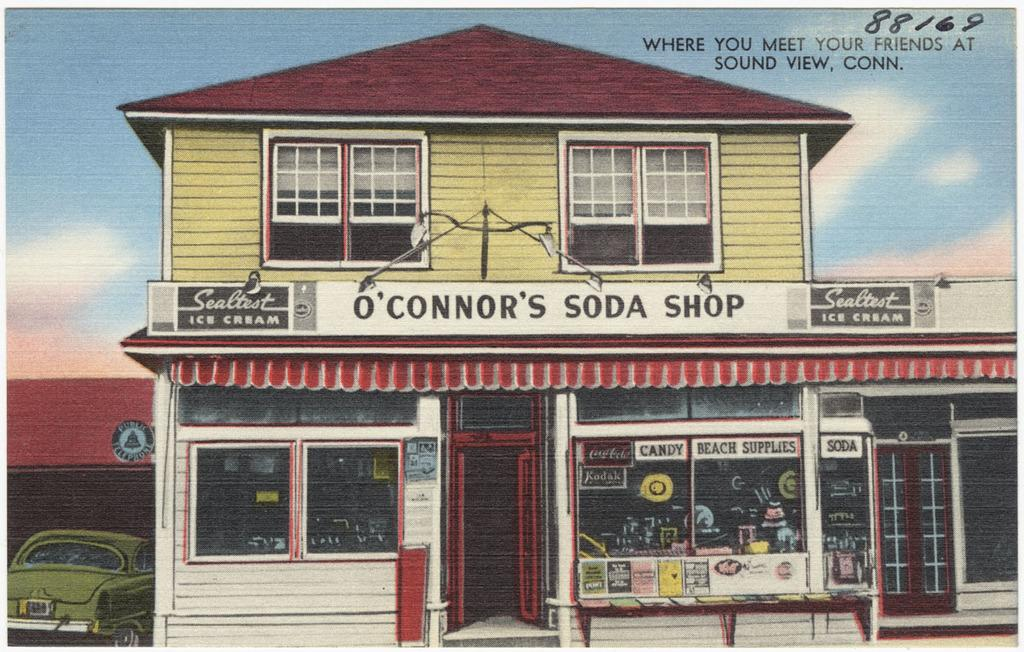What type of structure is in the image? There is a building in the image. What colors are used for the building? The building is white, red, and yellow in color. What vehicle can be seen in the image? There is a green car in the image. What can be seen in the background of the image? The sky is visible in the background of the image. What type of plant is being traded in the image? There is no plant or trade activity depicted in the image. What type of beef is being served at the event in the image? There is no event or beef present in the image. 